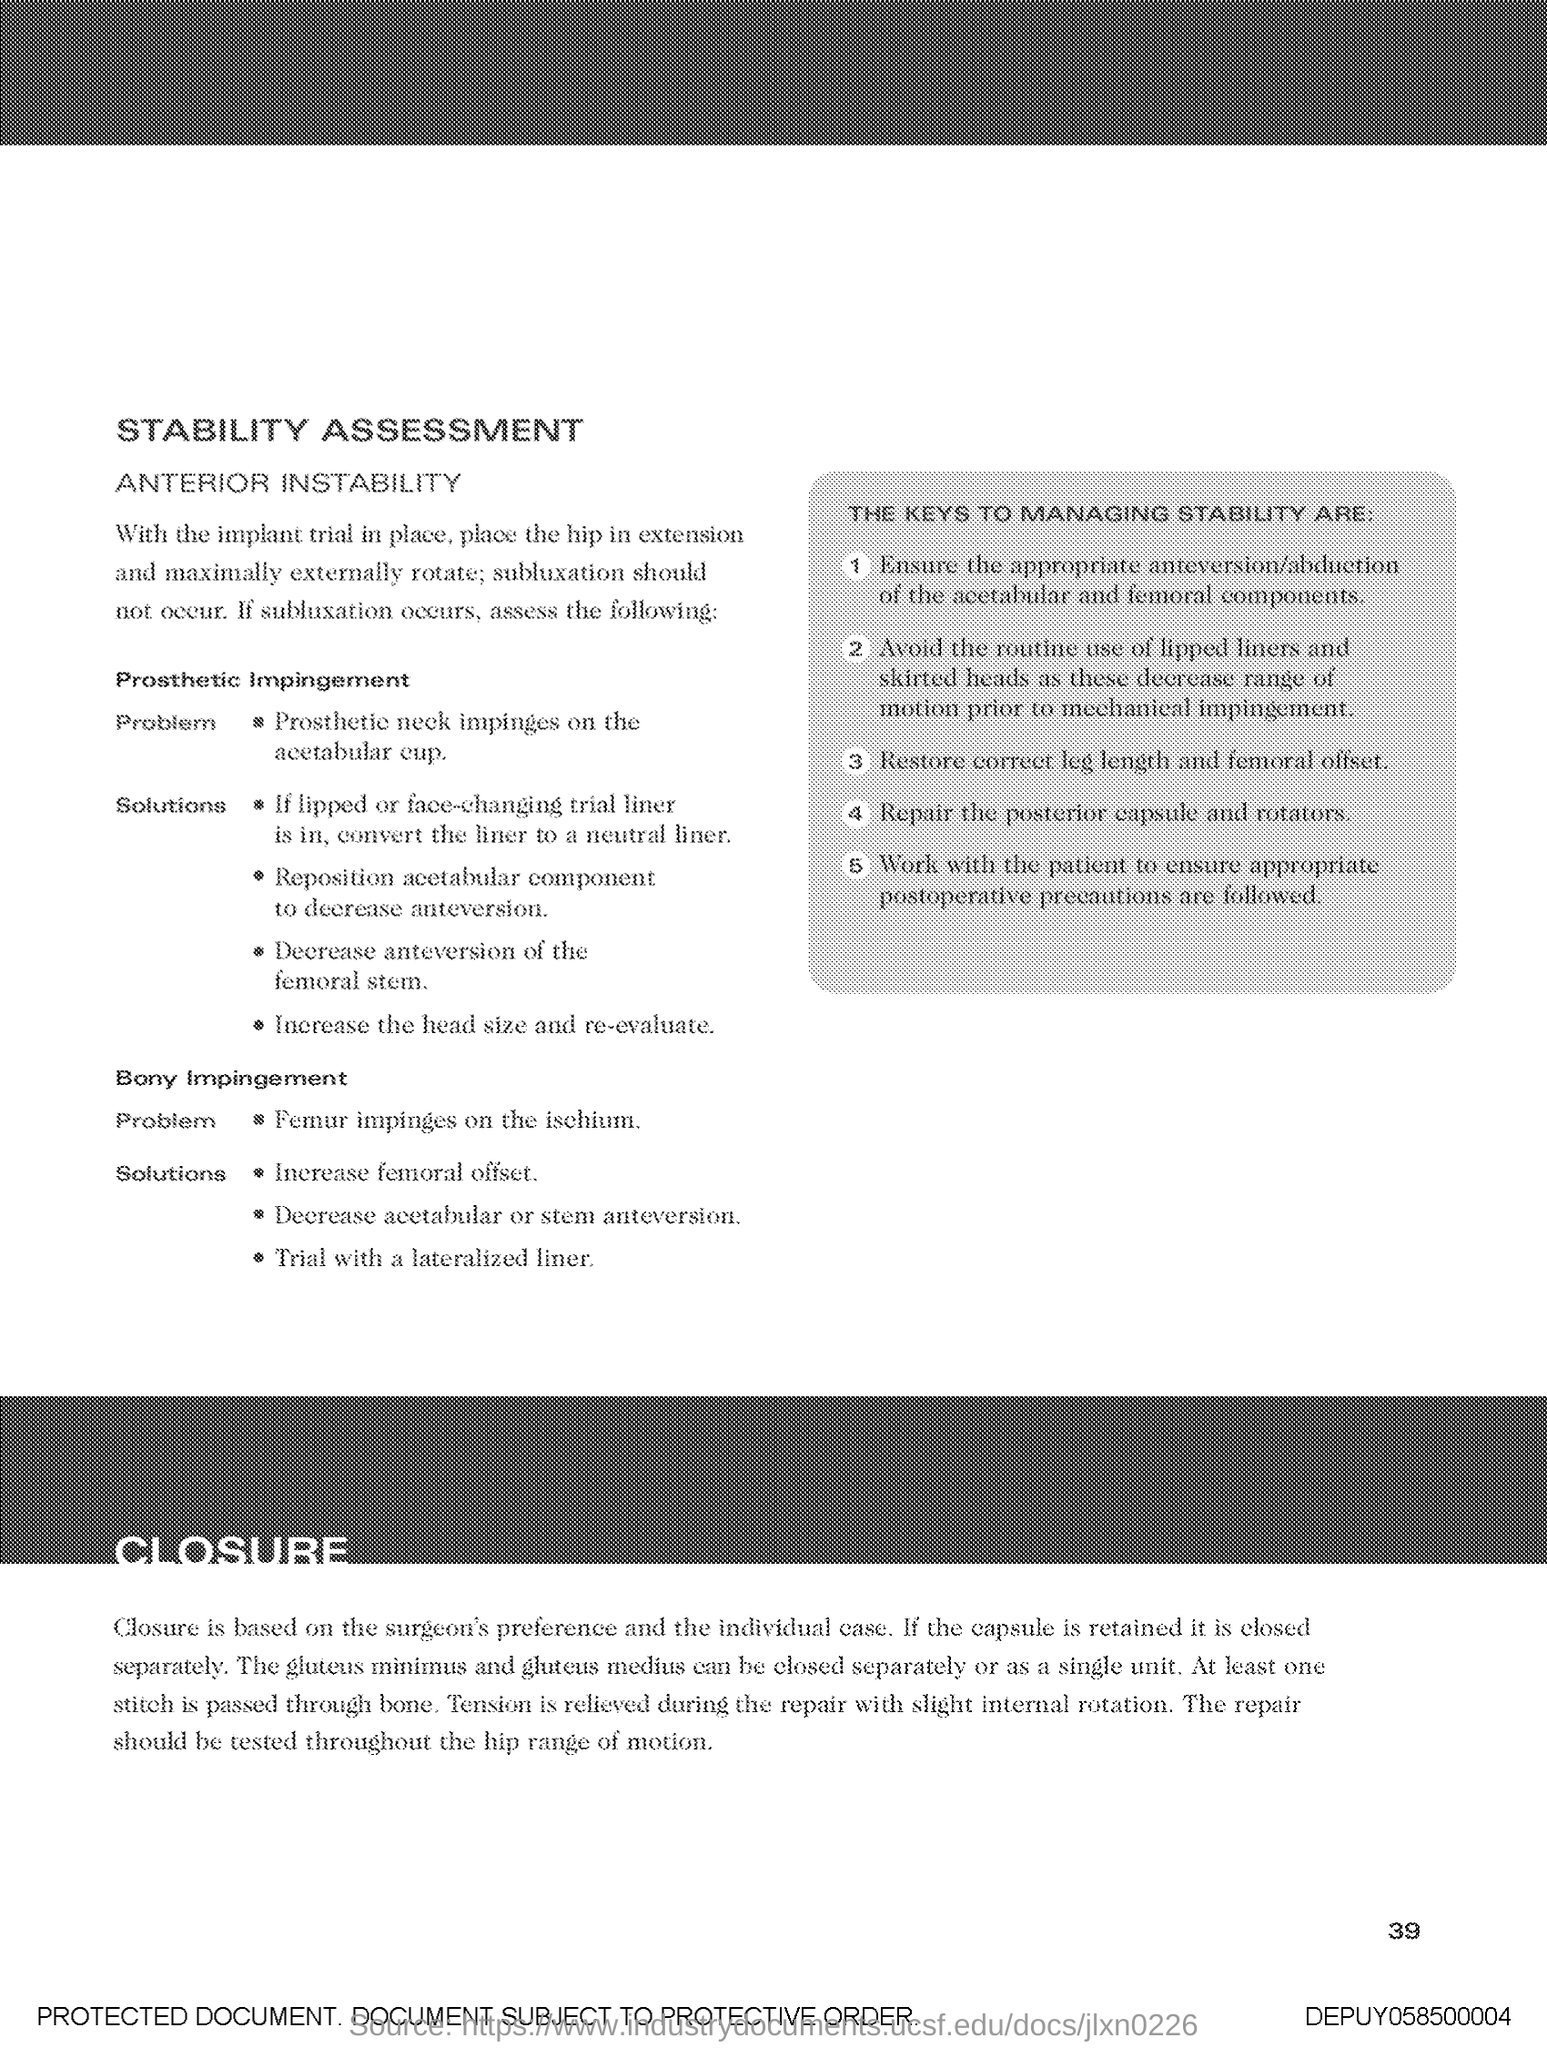What is the Page Number?
Your answer should be compact. 39. 